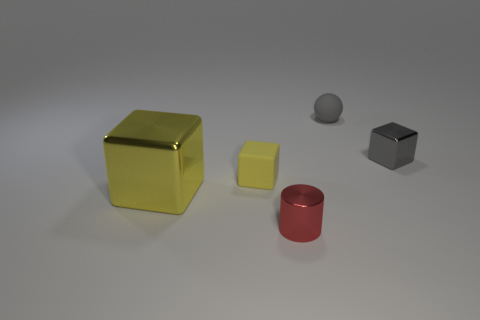Add 3 large yellow blocks. How many objects exist? 8 Subtract all spheres. How many objects are left? 4 Add 1 big metallic cubes. How many big metallic cubes are left? 2 Add 5 big gray matte cylinders. How many big gray matte cylinders exist? 5 Subtract 0 purple cylinders. How many objects are left? 5 Subtract all big yellow metallic blocks. Subtract all red cylinders. How many objects are left? 3 